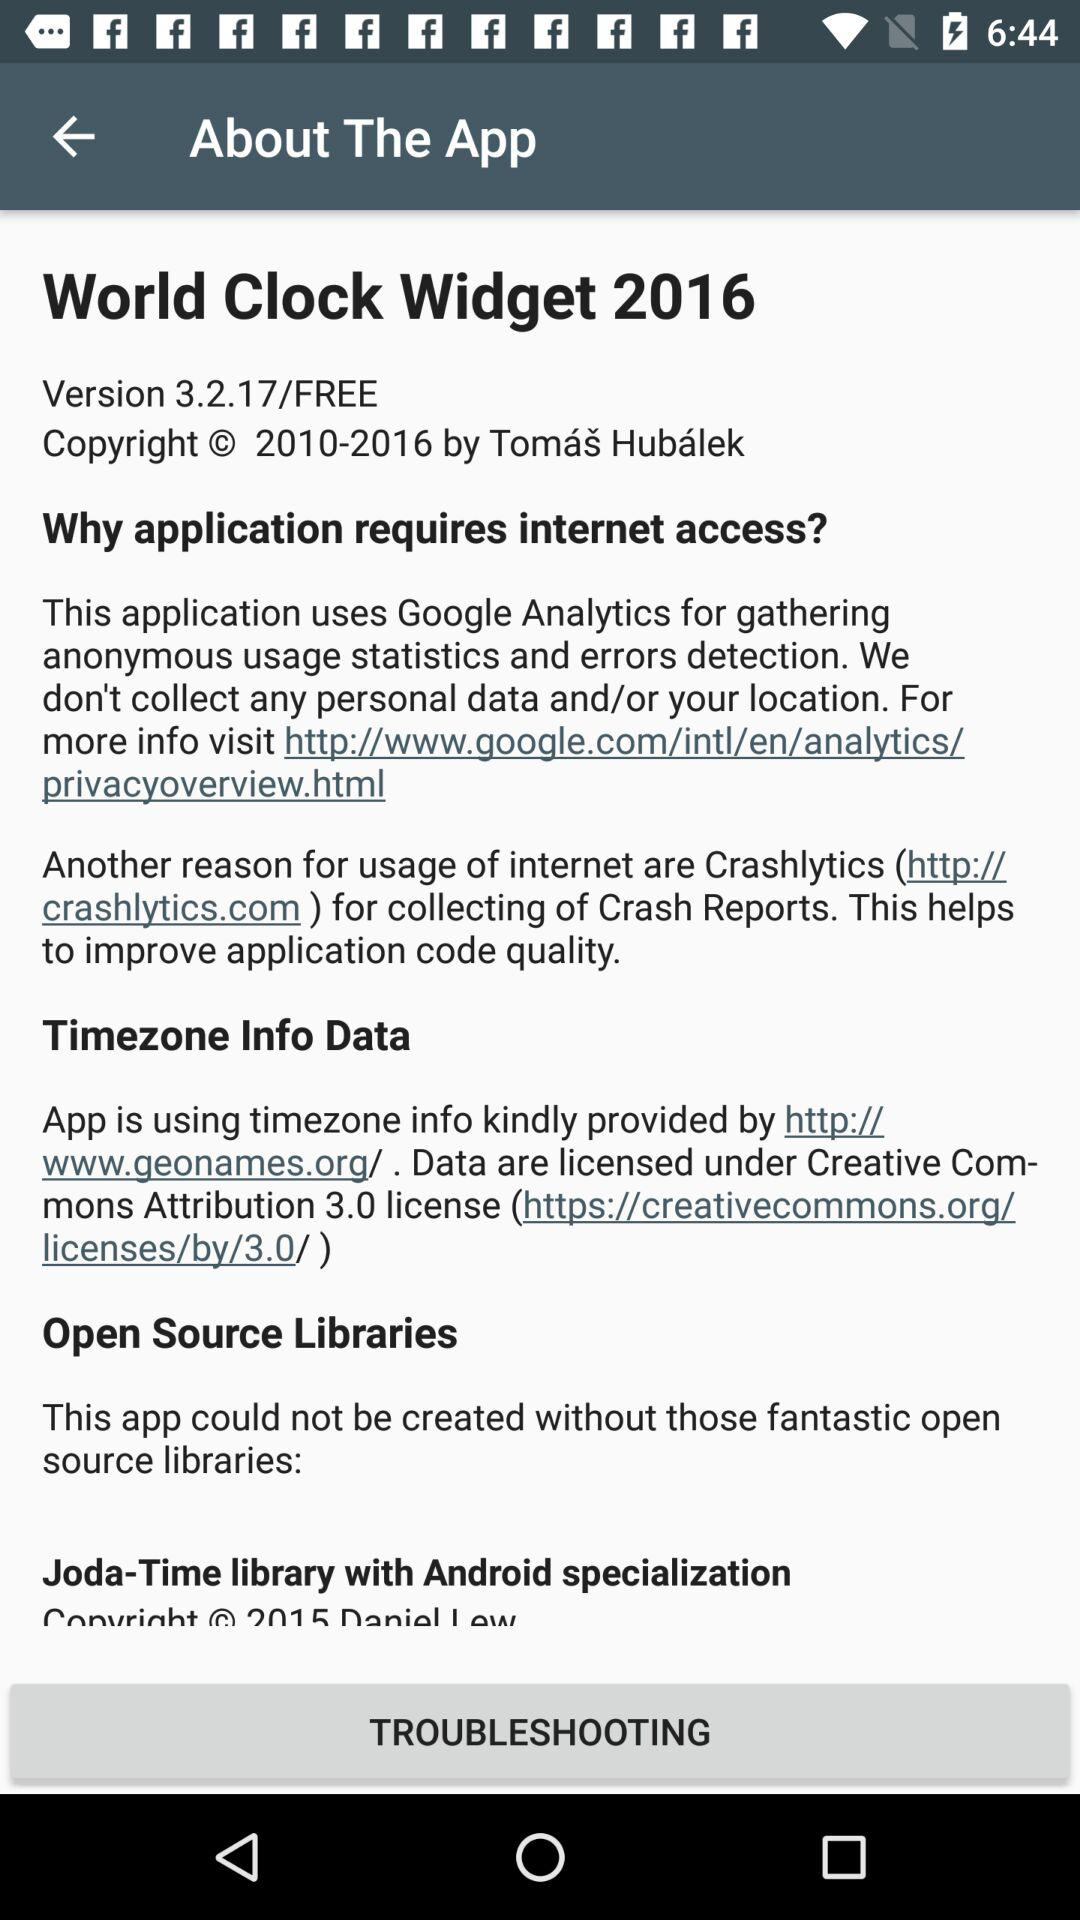What is the application name? The application name is "World Clock Widget 2016". 